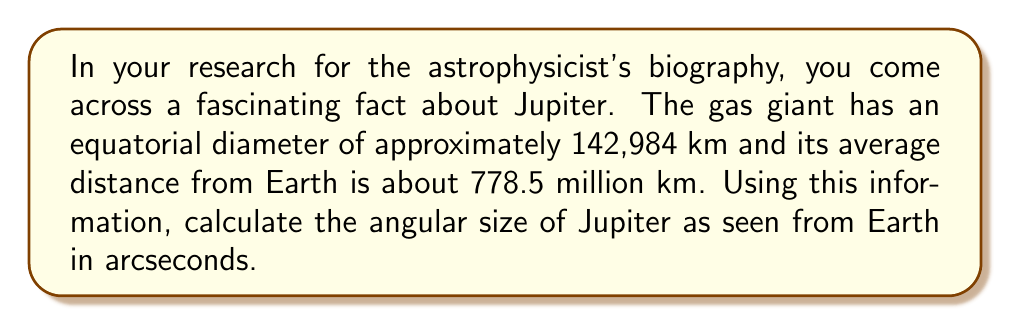Give your solution to this math problem. To find the angular size of Jupiter, we'll use the small-angle approximation formula:

$$ \theta \approx \frac{d}{D} \cdot \frac{180^\circ}{\pi} \cdot 3600" $$

Where:
$\theta$ = angular size in arcseconds
$d$ = actual diameter of the object
$D$ = distance to the object

Step 1: Insert the given values into the formula.
$d = 142,984 \text{ km}$
$D = 778.5 \text{ million km} = 778,500,000 \text{ km}$

$$ \theta \approx \frac{142,984}{778,500,000} \cdot \frac{180^\circ}{\pi} \cdot 3600" $$

Step 2: Simplify the fraction.
$$ \theta \approx 0.0001836 \cdot \frac{180^\circ}{\pi} \cdot 3600" $$

Step 3: Calculate the result.
$$ \theta \approx 0.0001836 \cdot 57.2958 \cdot 3600" $$
$$ \theta \approx 37.9" $$

Step 4: Round to the nearest whole number.
$$ \theta \approx 38" $$

Thus, the angular size of Jupiter as seen from Earth is approximately 38 arcseconds.
Answer: 38 arcseconds 